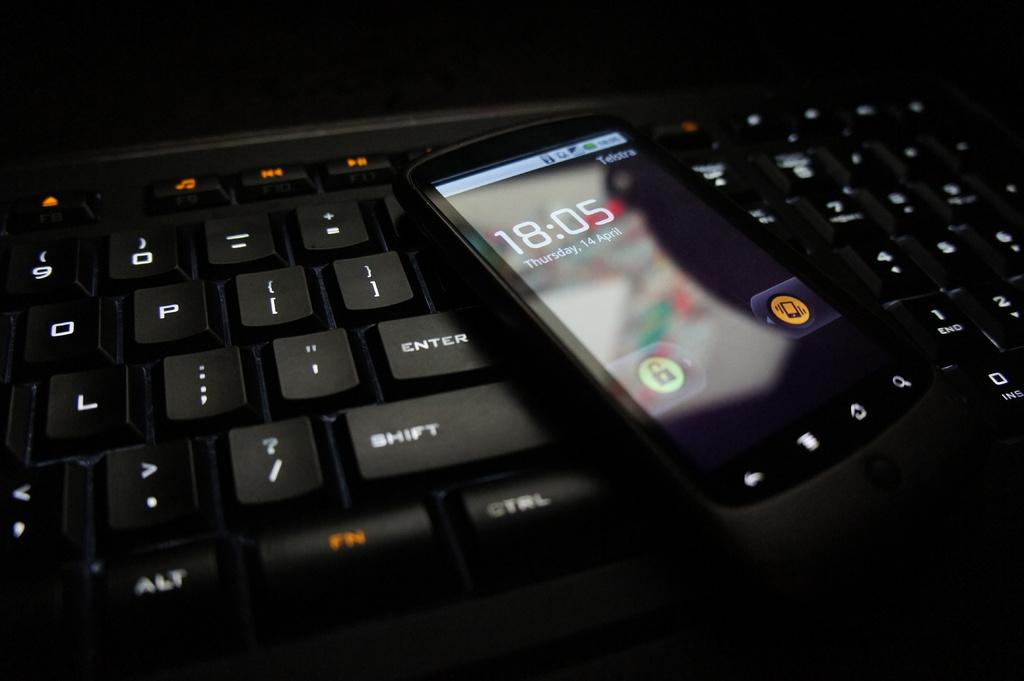<image>
Create a compact narrative representing the image presented. A cellphone with the time 18:05 sitting on top of a keyboard with light up keys. 